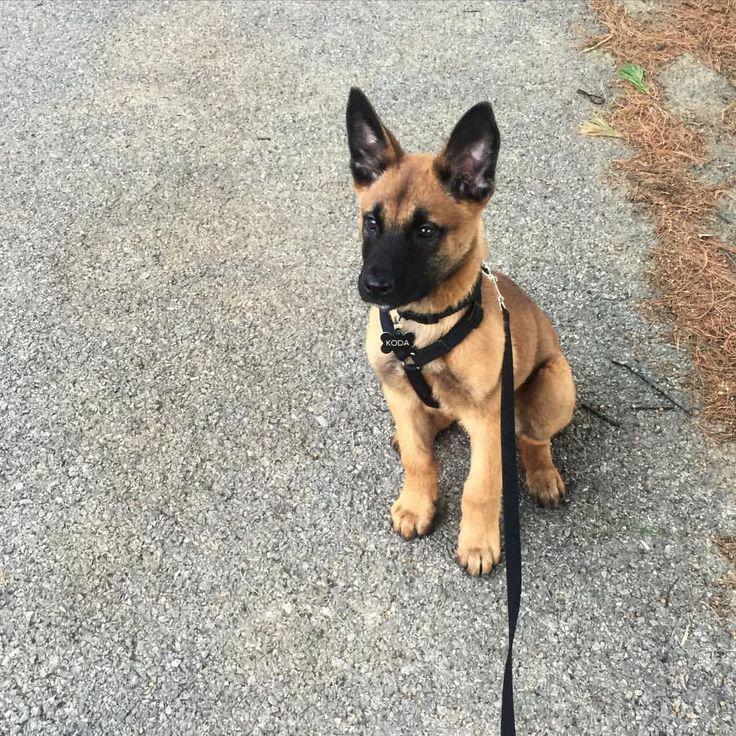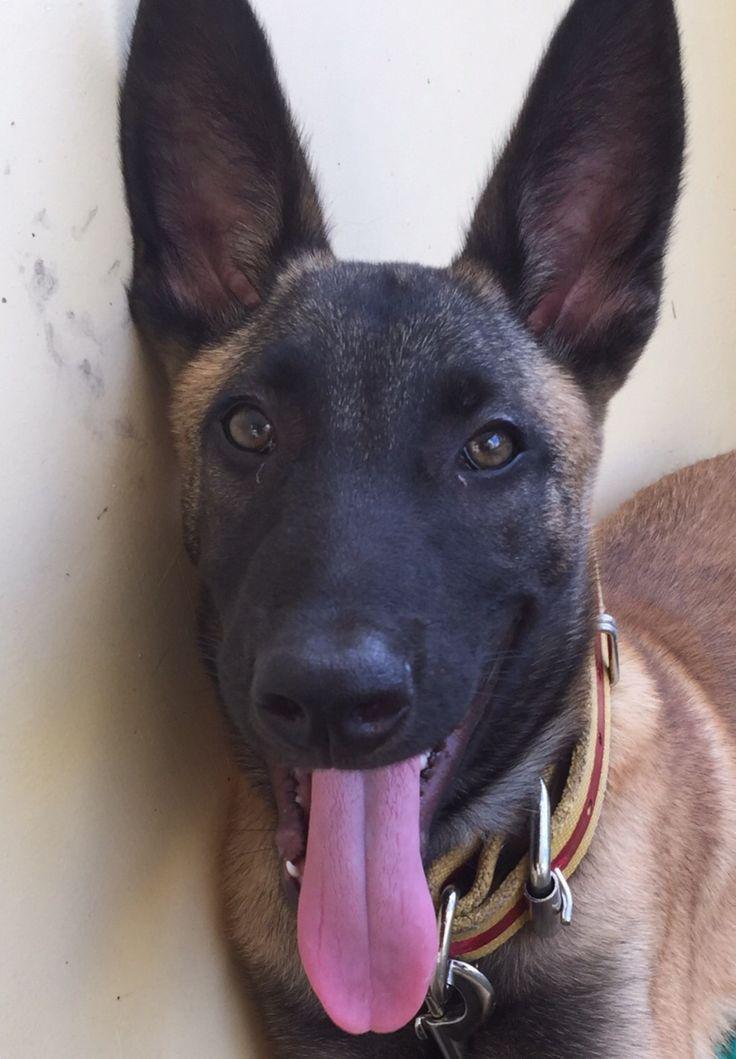The first image is the image on the left, the second image is the image on the right. For the images shown, is this caption "A dog is standing on all fours on a hard surface and wears a leash." true? Answer yes or no. No. The first image is the image on the left, the second image is the image on the right. Given the left and right images, does the statement "The dog in the image on the left is wearing a leash." hold true? Answer yes or no. Yes. 